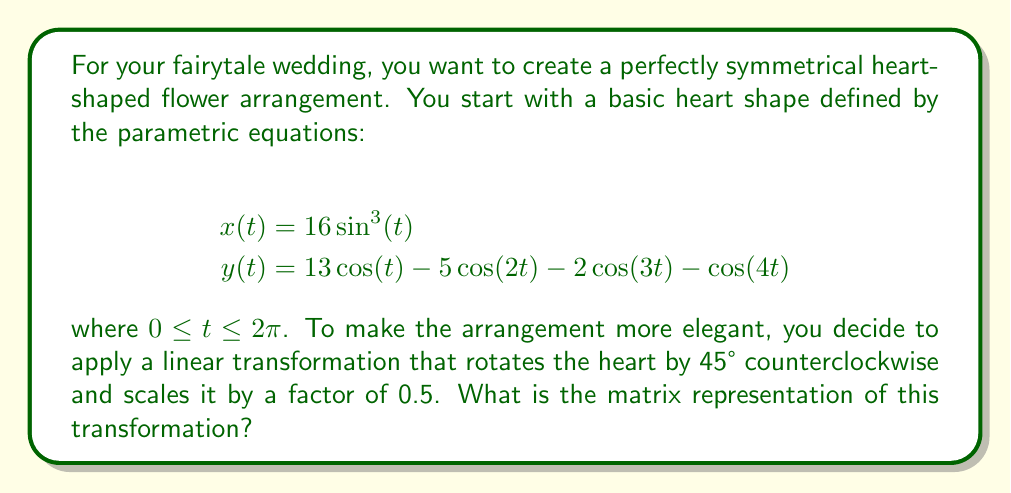Can you answer this question? To solve this problem, we need to combine two linear transformations: rotation and scaling. Let's break it down step-by-step:

1. Rotation matrix for 45° counterclockwise:
   The general form of a rotation matrix for angle θ is:
   $$R(\theta) = \begin{bmatrix} \cos(\theta) & -\sin(\theta) \\ \sin(\theta) & \cos(\theta) \end{bmatrix}$$
   
   For 45°, we have $\theta = \frac{\pi}{4}$, so:
   $$R(\frac{\pi}{4}) = \begin{bmatrix} \cos(\frac{\pi}{4}) & -\sin(\frac{\pi}{4}) \\ \sin(\frac{\pi}{4}) & \cos(\frac{\pi}{4}) \end{bmatrix} = \begin{bmatrix} \frac{\sqrt{2}}{2} & -\frac{\sqrt{2}}{2} \\ \frac{\sqrt{2}}{2} & \frac{\sqrt{2}}{2} \end{bmatrix}$$

2. Scaling matrix for a factor of 0.5:
   The general form of a scaling matrix is:
   $$S(k) = \begin{bmatrix} k & 0 \\ 0 & k \end{bmatrix}$$
   
   For a scale factor of 0.5, we have:
   $$S(0.5) = \begin{bmatrix} 0.5 & 0 \\ 0 & 0.5 \end{bmatrix}$$

3. To combine these transformations, we multiply the matrices in the order of application (scaling first, then rotation):
   $$T = R(\frac{\pi}{4}) \cdot S(0.5)$$
   
   $$T = \begin{bmatrix} \frac{\sqrt{2}}{2} & -\frac{\sqrt{2}}{2} \\ \frac{\sqrt{2}}{2} & \frac{\sqrt{2}}{2} \end{bmatrix} \cdot \begin{bmatrix} 0.5 & 0 \\ 0 & 0.5 \end{bmatrix}$$
   
   $$T = \begin{bmatrix} \frac{\sqrt{2}}{2} \cdot 0.5 & -\frac{\sqrt{2}}{2} \cdot 0.5 \\ \frac{\sqrt{2}}{2} \cdot 0.5 & \frac{\sqrt{2}}{2} \cdot 0.5 \end{bmatrix}$$
   
   $$T = \begin{bmatrix} \frac{\sqrt{2}}{4} & -\frac{\sqrt{2}}{4} \\ \frac{\sqrt{2}}{4} & \frac{\sqrt{2}}{4} \end{bmatrix}$$

This final matrix $T$ represents the combined transformation of scaling by 0.5 and rotating by 45° counterclockwise.
Answer: $$T = \begin{bmatrix} \frac{\sqrt{2}}{4} & -\frac{\sqrt{2}}{4} \\ \frac{\sqrt{2}}{4} & \frac{\sqrt{2}}{4} \end{bmatrix}$$ 